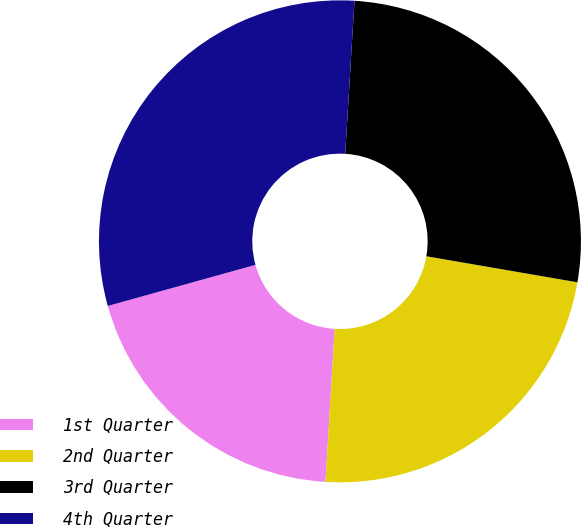Convert chart to OTSL. <chart><loc_0><loc_0><loc_500><loc_500><pie_chart><fcel>1st Quarter<fcel>2nd Quarter<fcel>3rd Quarter<fcel>4th Quarter<nl><fcel>19.72%<fcel>23.24%<fcel>26.76%<fcel>30.28%<nl></chart> 